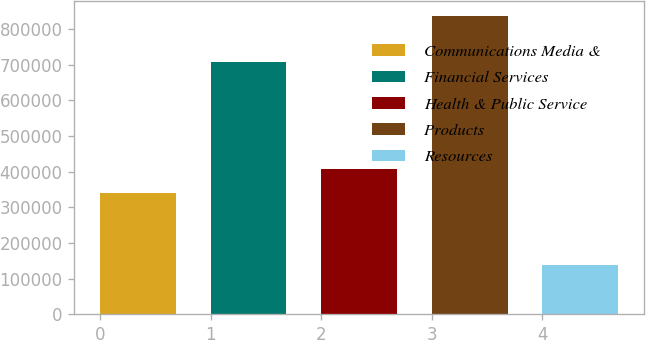Convert chart. <chart><loc_0><loc_0><loc_500><loc_500><bar_chart><fcel>Communications Media &<fcel>Financial Services<fcel>Health & Public Service<fcel>Products<fcel>Resources<nl><fcel>338855<fcel>707093<fcel>408737<fcel>836858<fcel>138036<nl></chart> 